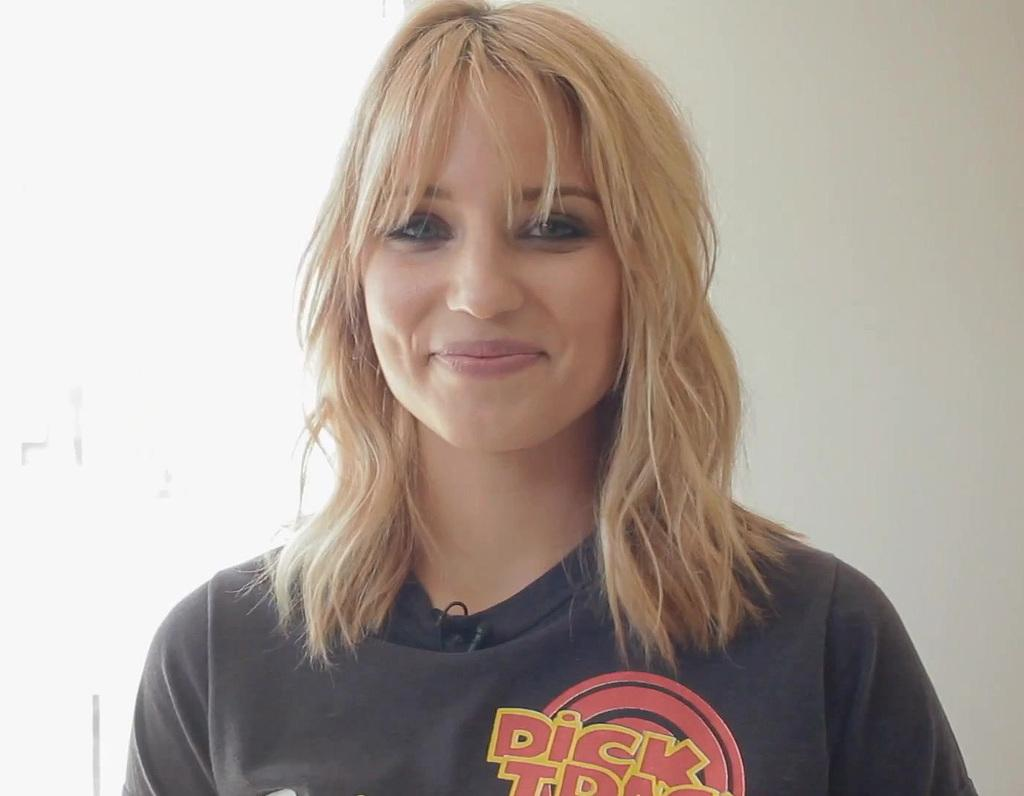<image>
Describe the image concisely. A DICK TRACY shirt is being worn by a smiling woman with blond hair. 